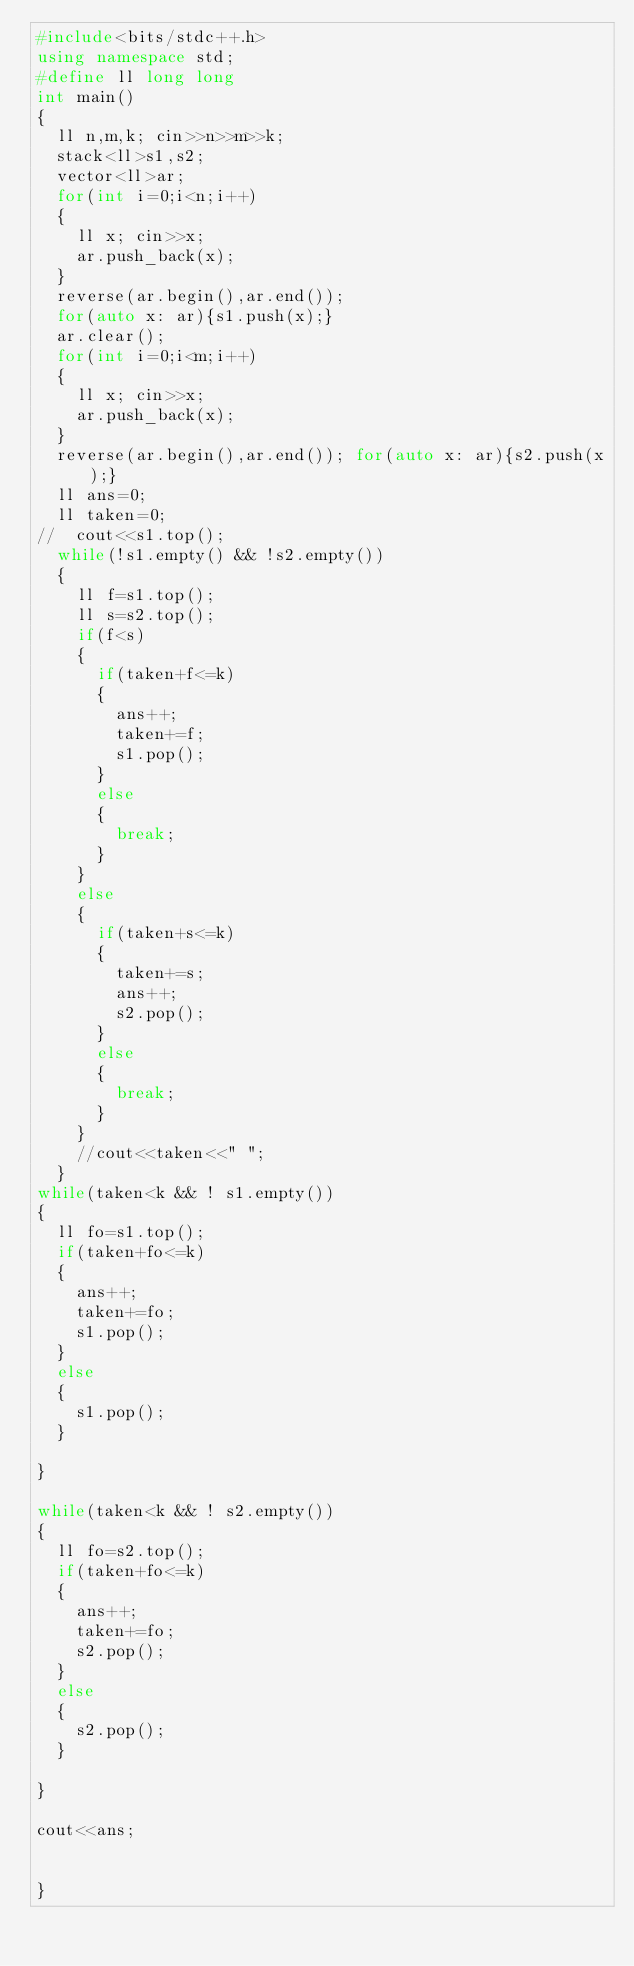Convert code to text. <code><loc_0><loc_0><loc_500><loc_500><_C++_>#include<bits/stdc++.h>
using namespace std;
#define ll long long
int main() 
{
	ll n,m,k; cin>>n>>m>>k;
	stack<ll>s1,s2;
	vector<ll>ar;
	for(int i=0;i<n;i++)
	{
		ll x; cin>>x;
		ar.push_back(x);
	}
	reverse(ar.begin(),ar.end());
	for(auto x: ar){s1.push(x);}
	ar.clear();
	for(int i=0;i<m;i++)
	{
		ll x; cin>>x;
		ar.push_back(x);
	}
	reverse(ar.begin(),ar.end()); for(auto x: ar){s2.push(x);}
	ll ans=0;
	ll taken=0;
//	cout<<s1.top();
	while(!s1.empty() && !s2.empty())
	{
		ll f=s1.top();
		ll s=s2.top();
		if(f<s)
		{
			if(taken+f<=k)
			{
				ans++;
				taken+=f;
				s1.pop();
			}
			else
			{
				break;
			}
		}
		else
		{
			if(taken+s<=k)
			{
				taken+=s;
				ans++;
				s2.pop();
			}
			else
			{
				break;
			}
		}
		//cout<<taken<<" ";
	}
while(taken<k && ! s1.empty())
{
	ll fo=s1.top();
	if(taken+fo<=k)
	{
		ans++;
		taken+=fo;
		s1.pop();
	}
	else
	{
		s1.pop();
	}
	
}
	
while(taken<k && ! s2.empty())
{
	ll fo=s2.top();
	if(taken+fo<=k)
	{
		ans++;
		taken+=fo;
		s2.pop();
	}
	else
	{
		s2.pop();
	}
	
}
		
cout<<ans;


}</code> 